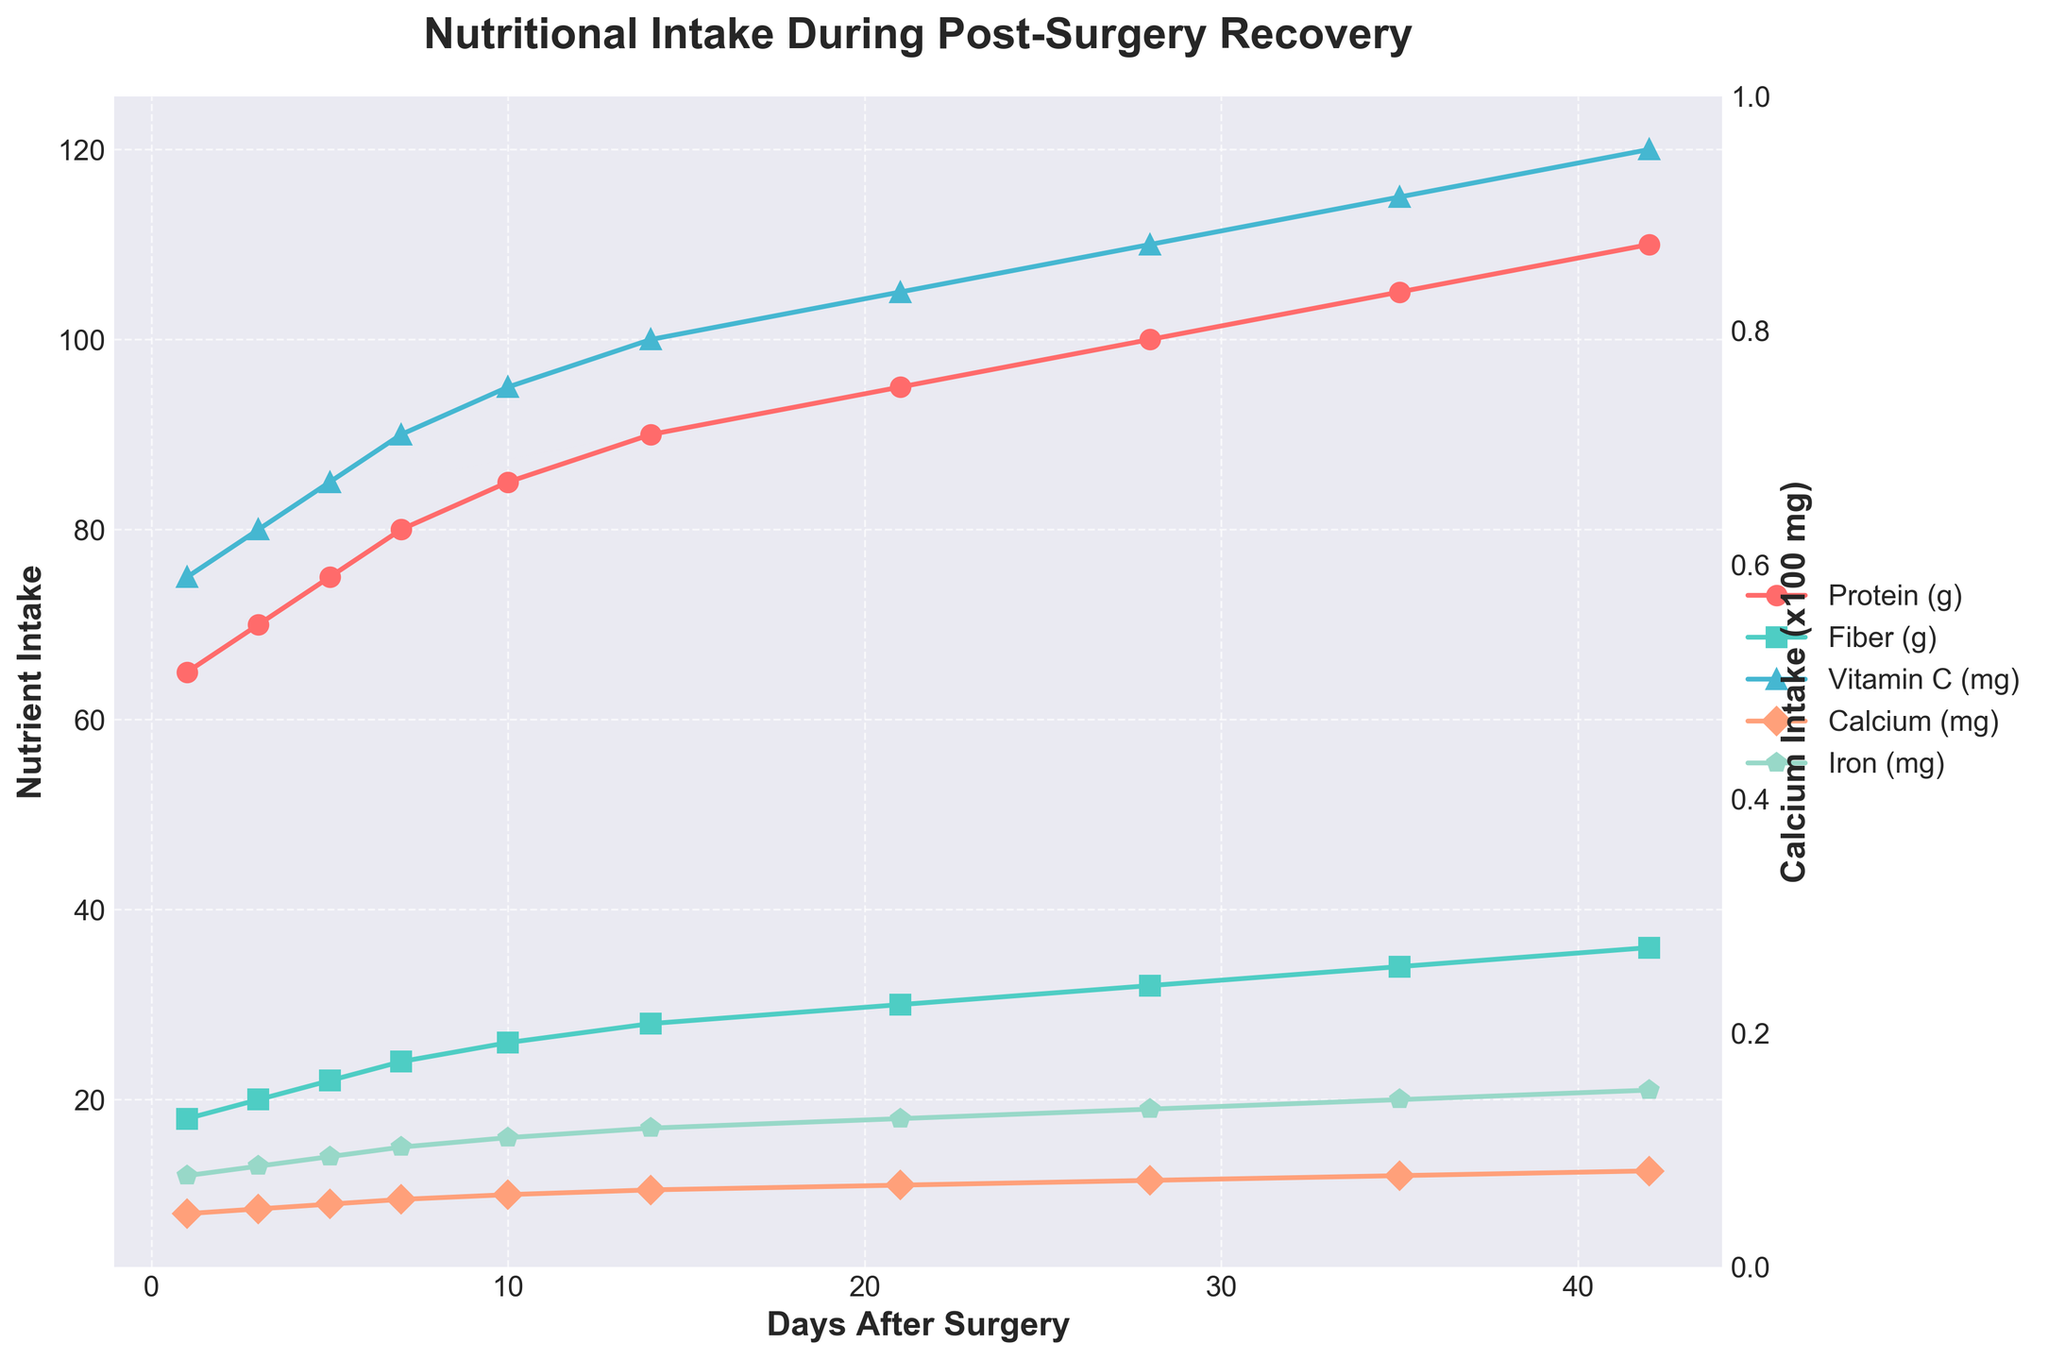What trend is observed in protein intake over the recovery period? The line representing protein intake starts at 65g on Day 1 and gradually increases, reaching 110g on Day 42. To identify the trend, focus on the positive slope indicating a consistent rise in protein intake over time.
Answer: Increasing Which nutrient shows the least change between Day 1 and Day 42? Protein intake changes from 65g to 110g, Fiber from 18g to 36g, Vitamin C from 75mg to 120mg, Calcium from 800mg to 1250mg, and Iron from 12mg to 21mg. Calculating the difference for each: Protein (45g), Fiber (18g), Vitamin C (45mg), Calcium (450mg), Iron (9mg). The smallest difference is in fiber intake (18g).
Answer: Fiber By how much did calcium intake increase from Day 1 to Day 21? On Day 1, calcium intake was 800mg, and on Day 21, it was 1100mg. The increase is calculated as 1100mg - 800mg = 300mg.
Answer: 300mg How does the vitamin C intake on Day 10 compare to that on Day 35? On Day 10, the intake of vitamin C is 95mg, and on Day 35, it is 115mg. The difference is 115mg - 95mg = 20mg, indicating an increase.
Answer: Higher on Day 35 What is the average daily increase in protein intake between Day 1 and Day 42? The total increase in protein intake from Day 1 to Day 42 is 110g - 65g = 45g. The time span is 42 days - 1 day = 41 days. The average daily increase is 45g / 41 days ≈ 1.10g/day.
Answer: 1.10g/day At which time point does fiber intake reach 30 grams? Looking at the plot, fiber intake reaches 30g on Day 21.
Answer: Day 21 Compare the trends of iron and fiber intake over the recovery period. Both iron and fiber intakes show an increasing trend over time. Iron intake increases steadily from 12mg to 21mg, while fiber intake rises from 18g to 36g. Both lines slope upward, indicating a consistent increase.
Answer: Both increase How does the trend for calcium intake differ from the other nutrients? Calcium intake is plotted on a separate y-axis scaled by 100. Similar to other nutrients, the trend shows an increase over time but with a higher magnitude changes scaled appropriately.
Answer: Scaled separately, still increasing What days show the same change in iron and vitamin C intake? From Day 1 to Day 42, Iron intake increases by 9mg (12 to 21mg) and Vitamin C by 45mg (75 to 120mg). On proportional analysis: Day 5 and Day 21 both show similar fractional changes in intake for iron and vitamin C when considering their proportional increase in intervals.
Answer: Day 5, Day 21 Which nutrient had the steepest increase from Day 28 to Day 35? Comparing differences from Day 28 to Day 35: Protein (100g to 105g = 5g), Fiber (32g to 34g = 2g), Vitamin C (110mg to 115mg = 5mg), Calcium (1150mg/100 to 1200mg/100 = 0.5), and Iron (19mg to 20 mg = 1mg). The steepest slope is in protein and vitamin C's increase.
Answer: Protein, Vitamin C 